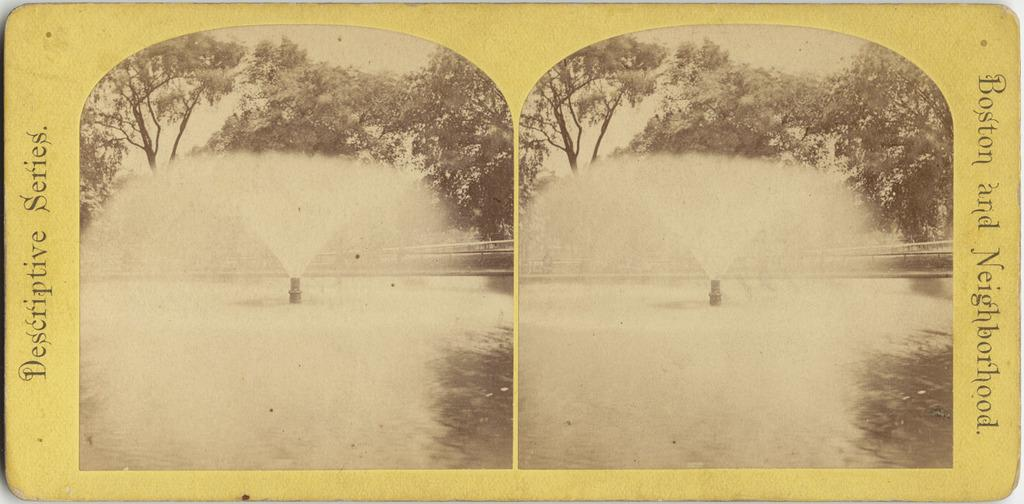What color is the object in the image? The object in the image is yellow. What images are depicted on the object? The object has two pictures of a fountain, trees, and the sky. Is there any text on the object? Yes, there is text written on the object. What type of punishment is being given to the toys in the image? There are no toys present in the image, and therefore no punishment can be observed. 